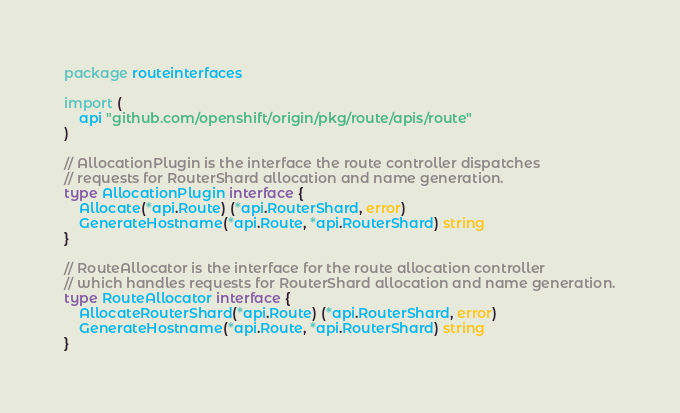<code> <loc_0><loc_0><loc_500><loc_500><_Go_>package routeinterfaces

import (
	api "github.com/openshift/origin/pkg/route/apis/route"
)

// AllocationPlugin is the interface the route controller dispatches
// requests for RouterShard allocation and name generation.
type AllocationPlugin interface {
	Allocate(*api.Route) (*api.RouterShard, error)
	GenerateHostname(*api.Route, *api.RouterShard) string
}

// RouteAllocator is the interface for the route allocation controller
// which handles requests for RouterShard allocation and name generation.
type RouteAllocator interface {
	AllocateRouterShard(*api.Route) (*api.RouterShard, error)
	GenerateHostname(*api.Route, *api.RouterShard) string
}
</code> 